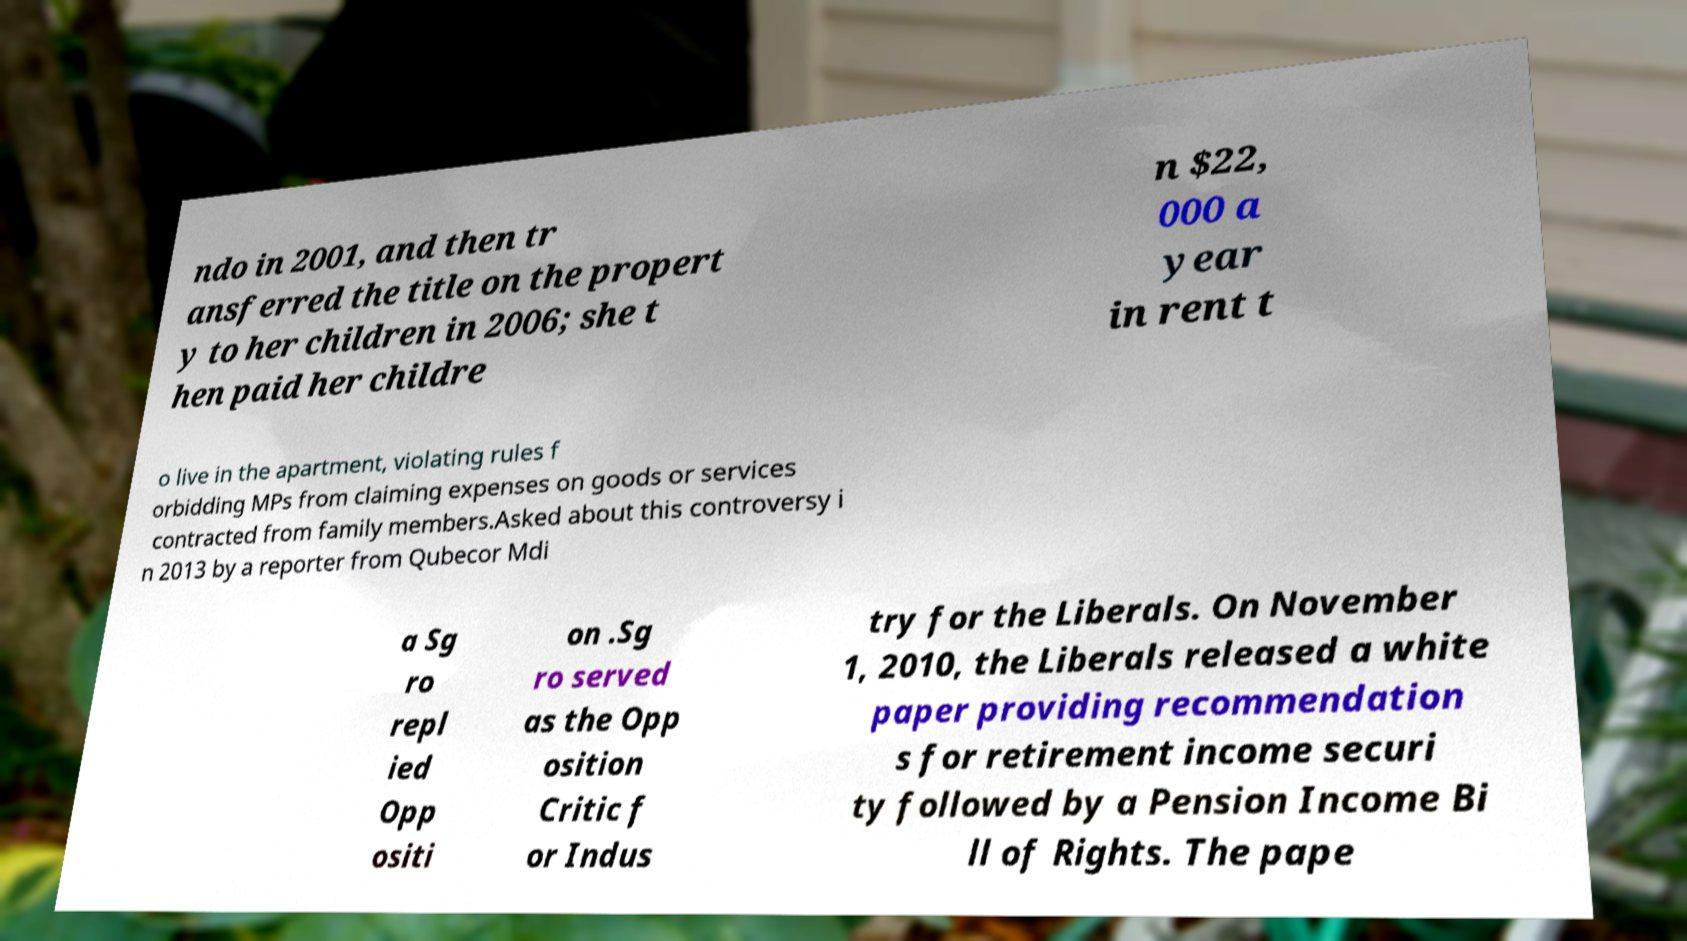For documentation purposes, I need the text within this image transcribed. Could you provide that? ndo in 2001, and then tr ansferred the title on the propert y to her children in 2006; she t hen paid her childre n $22, 000 a year in rent t o live in the apartment, violating rules f orbidding MPs from claiming expenses on goods or services contracted from family members.Asked about this controversy i n 2013 by a reporter from Qubecor Mdi a Sg ro repl ied Opp ositi on .Sg ro served as the Opp osition Critic f or Indus try for the Liberals. On November 1, 2010, the Liberals released a white paper providing recommendation s for retirement income securi ty followed by a Pension Income Bi ll of Rights. The pape 